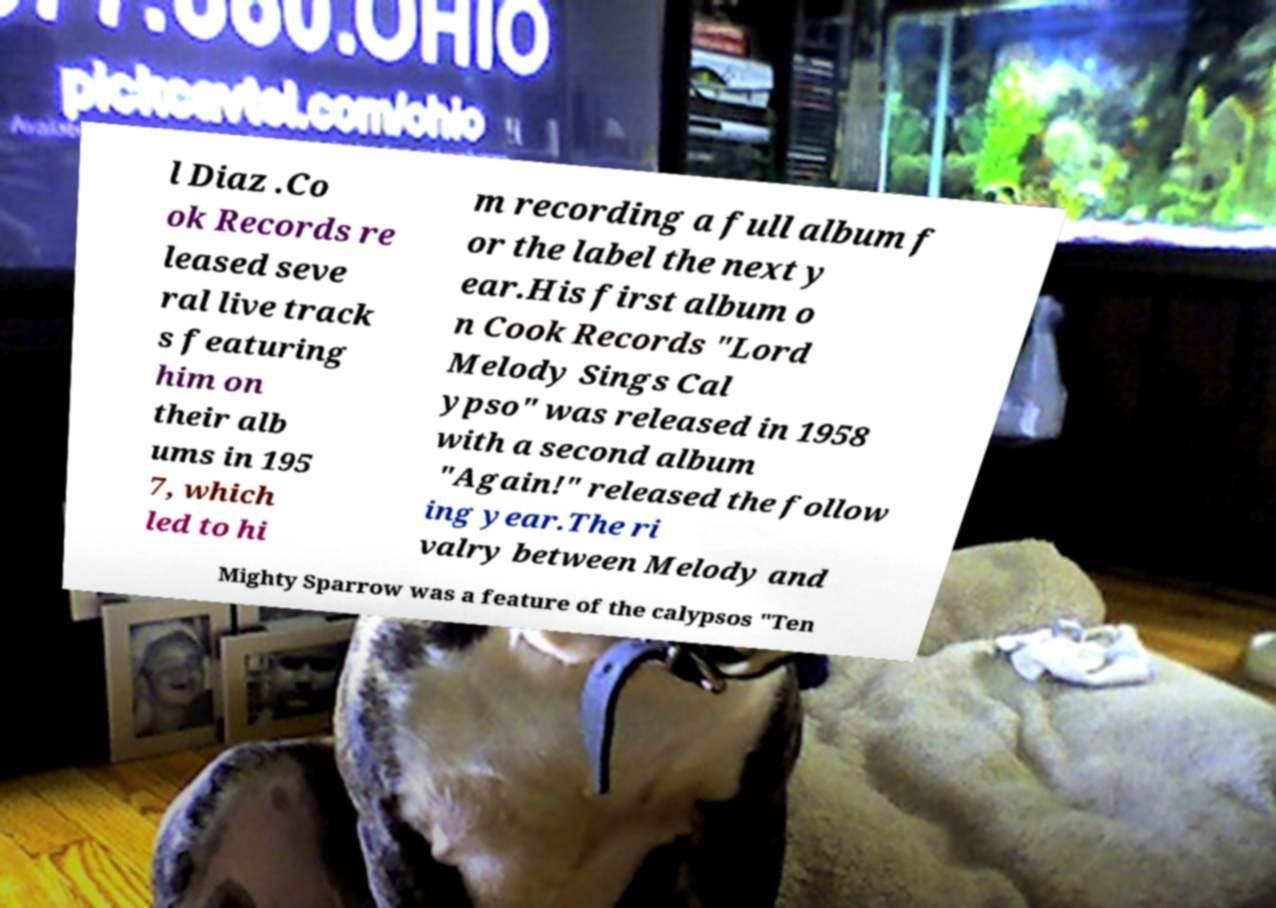Can you accurately transcribe the text from the provided image for me? l Diaz .Co ok Records re leased seve ral live track s featuring him on their alb ums in 195 7, which led to hi m recording a full album f or the label the next y ear.His first album o n Cook Records "Lord Melody Sings Cal ypso" was released in 1958 with a second album "Again!" released the follow ing year.The ri valry between Melody and Mighty Sparrow was a feature of the calypsos "Ten 